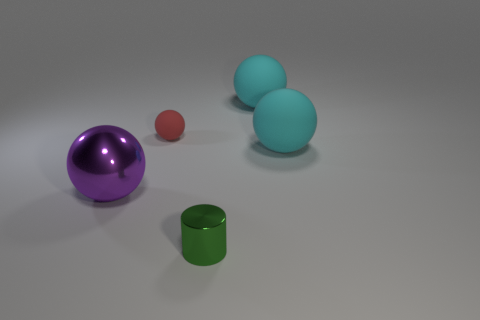What materials are the objects in the image made of? The objects appear to have different materials. The spheres seem glossy, perhaps made of polished stone or plastic, while the metallic cylinder has a matte finish indicating it might be made of metal. 